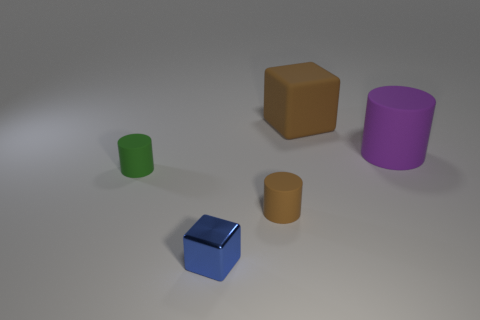Add 1 large objects. How many objects exist? 6 Subtract all blocks. How many objects are left? 3 Add 1 green rubber things. How many green rubber things exist? 2 Subtract 1 brown cylinders. How many objects are left? 4 Subtract all small red rubber cylinders. Subtract all tiny green objects. How many objects are left? 4 Add 5 brown cylinders. How many brown cylinders are left? 6 